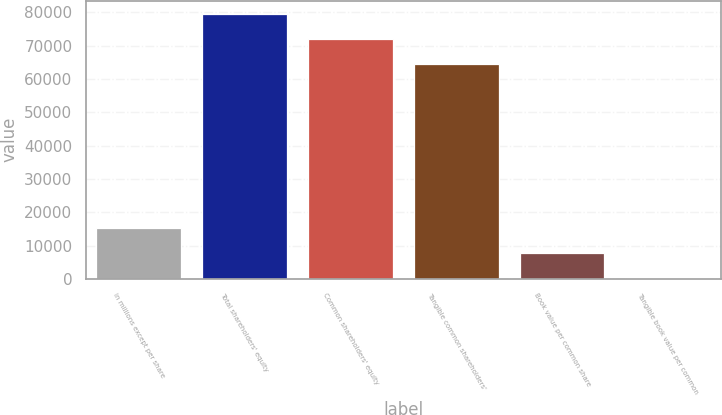Convert chart. <chart><loc_0><loc_0><loc_500><loc_500><bar_chart><fcel>in millions except per share<fcel>Total shareholders' equity<fcel>Common shareholders' equity<fcel>Tangible common shareholders'<fcel>Book value per common share<fcel>Tangible book value per common<nl><fcel>15250.4<fcel>79533.4<fcel>71975.2<fcel>64417<fcel>7692.25<fcel>134.06<nl></chart> 